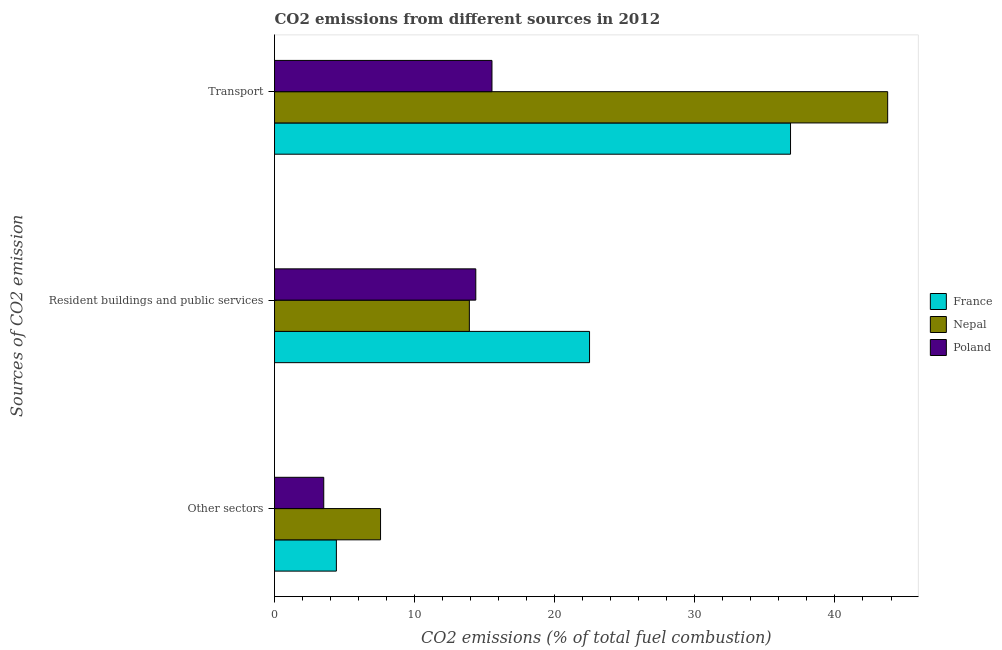Are the number of bars on each tick of the Y-axis equal?
Your response must be concise. Yes. How many bars are there on the 2nd tick from the top?
Your answer should be very brief. 3. What is the label of the 1st group of bars from the top?
Provide a short and direct response. Transport. What is the percentage of co2 emissions from resident buildings and public services in France?
Offer a very short reply. 22.48. Across all countries, what is the maximum percentage of co2 emissions from other sectors?
Offer a terse response. 7.57. Across all countries, what is the minimum percentage of co2 emissions from transport?
Make the answer very short. 15.52. In which country was the percentage of co2 emissions from resident buildings and public services maximum?
Your answer should be very brief. France. In which country was the percentage of co2 emissions from resident buildings and public services minimum?
Offer a very short reply. Nepal. What is the total percentage of co2 emissions from transport in the graph?
Make the answer very short. 96.11. What is the difference between the percentage of co2 emissions from transport in Poland and that in France?
Your answer should be very brief. -21.31. What is the difference between the percentage of co2 emissions from resident buildings and public services in Poland and the percentage of co2 emissions from other sectors in France?
Keep it short and to the point. 9.95. What is the average percentage of co2 emissions from resident buildings and public services per country?
Ensure brevity in your answer.  16.92. What is the difference between the percentage of co2 emissions from resident buildings and public services and percentage of co2 emissions from transport in Nepal?
Make the answer very short. -29.86. In how many countries, is the percentage of co2 emissions from other sectors greater than 2 %?
Your response must be concise. 3. What is the ratio of the percentage of co2 emissions from transport in Nepal to that in France?
Make the answer very short. 1.19. Is the percentage of co2 emissions from transport in Nepal less than that in Poland?
Provide a short and direct response. No. Is the difference between the percentage of co2 emissions from resident buildings and public services in Nepal and Poland greater than the difference between the percentage of co2 emissions from other sectors in Nepal and Poland?
Give a very brief answer. No. What is the difference between the highest and the second highest percentage of co2 emissions from transport?
Give a very brief answer. 6.93. What is the difference between the highest and the lowest percentage of co2 emissions from other sectors?
Keep it short and to the point. 4.05. In how many countries, is the percentage of co2 emissions from other sectors greater than the average percentage of co2 emissions from other sectors taken over all countries?
Your response must be concise. 1. Is the sum of the percentage of co2 emissions from transport in Nepal and Poland greater than the maximum percentage of co2 emissions from other sectors across all countries?
Provide a succinct answer. Yes. What does the 2nd bar from the bottom in Other sectors represents?
Your response must be concise. Nepal. Is it the case that in every country, the sum of the percentage of co2 emissions from other sectors and percentage of co2 emissions from resident buildings and public services is greater than the percentage of co2 emissions from transport?
Give a very brief answer. No. How many bars are there?
Provide a succinct answer. 9. What is the difference between two consecutive major ticks on the X-axis?
Your answer should be very brief. 10. Does the graph contain grids?
Provide a short and direct response. No. How many legend labels are there?
Make the answer very short. 3. How are the legend labels stacked?
Provide a succinct answer. Vertical. What is the title of the graph?
Your answer should be very brief. CO2 emissions from different sources in 2012. What is the label or title of the X-axis?
Make the answer very short. CO2 emissions (% of total fuel combustion). What is the label or title of the Y-axis?
Ensure brevity in your answer.  Sources of CO2 emission. What is the CO2 emissions (% of total fuel combustion) of France in Other sectors?
Make the answer very short. 4.41. What is the CO2 emissions (% of total fuel combustion) of Nepal in Other sectors?
Make the answer very short. 7.57. What is the CO2 emissions (% of total fuel combustion) in Poland in Other sectors?
Provide a short and direct response. 3.51. What is the CO2 emissions (% of total fuel combustion) of France in Resident buildings and public services?
Provide a succinct answer. 22.48. What is the CO2 emissions (% of total fuel combustion) of Nepal in Resident buildings and public services?
Provide a succinct answer. 13.91. What is the CO2 emissions (% of total fuel combustion) of Poland in Resident buildings and public services?
Offer a very short reply. 14.36. What is the CO2 emissions (% of total fuel combustion) in France in Transport?
Provide a succinct answer. 36.83. What is the CO2 emissions (% of total fuel combustion) of Nepal in Transport?
Keep it short and to the point. 43.76. What is the CO2 emissions (% of total fuel combustion) of Poland in Transport?
Your answer should be very brief. 15.52. Across all Sources of CO2 emission, what is the maximum CO2 emissions (% of total fuel combustion) in France?
Offer a terse response. 36.83. Across all Sources of CO2 emission, what is the maximum CO2 emissions (% of total fuel combustion) of Nepal?
Make the answer very short. 43.76. Across all Sources of CO2 emission, what is the maximum CO2 emissions (% of total fuel combustion) in Poland?
Provide a succinct answer. 15.52. Across all Sources of CO2 emission, what is the minimum CO2 emissions (% of total fuel combustion) in France?
Make the answer very short. 4.41. Across all Sources of CO2 emission, what is the minimum CO2 emissions (% of total fuel combustion) of Nepal?
Give a very brief answer. 7.57. Across all Sources of CO2 emission, what is the minimum CO2 emissions (% of total fuel combustion) of Poland?
Provide a succinct answer. 3.51. What is the total CO2 emissions (% of total fuel combustion) in France in the graph?
Provide a short and direct response. 63.73. What is the total CO2 emissions (% of total fuel combustion) in Nepal in the graph?
Provide a short and direct response. 65.24. What is the total CO2 emissions (% of total fuel combustion) in Poland in the graph?
Provide a succinct answer. 33.4. What is the difference between the CO2 emissions (% of total fuel combustion) of France in Other sectors and that in Resident buildings and public services?
Your answer should be very brief. -18.07. What is the difference between the CO2 emissions (% of total fuel combustion) of Nepal in Other sectors and that in Resident buildings and public services?
Provide a short and direct response. -6.34. What is the difference between the CO2 emissions (% of total fuel combustion) in Poland in Other sectors and that in Resident buildings and public services?
Make the answer very short. -10.85. What is the difference between the CO2 emissions (% of total fuel combustion) in France in Other sectors and that in Transport?
Provide a succinct answer. -32.41. What is the difference between the CO2 emissions (% of total fuel combustion) of Nepal in Other sectors and that in Transport?
Provide a short and direct response. -36.2. What is the difference between the CO2 emissions (% of total fuel combustion) of Poland in Other sectors and that in Transport?
Your response must be concise. -12.01. What is the difference between the CO2 emissions (% of total fuel combustion) in France in Resident buildings and public services and that in Transport?
Your answer should be very brief. -14.35. What is the difference between the CO2 emissions (% of total fuel combustion) in Nepal in Resident buildings and public services and that in Transport?
Your answer should be very brief. -29.86. What is the difference between the CO2 emissions (% of total fuel combustion) of Poland in Resident buildings and public services and that in Transport?
Give a very brief answer. -1.15. What is the difference between the CO2 emissions (% of total fuel combustion) in France in Other sectors and the CO2 emissions (% of total fuel combustion) in Nepal in Resident buildings and public services?
Make the answer very short. -9.49. What is the difference between the CO2 emissions (% of total fuel combustion) of France in Other sectors and the CO2 emissions (% of total fuel combustion) of Poland in Resident buildings and public services?
Keep it short and to the point. -9.95. What is the difference between the CO2 emissions (% of total fuel combustion) of Nepal in Other sectors and the CO2 emissions (% of total fuel combustion) of Poland in Resident buildings and public services?
Make the answer very short. -6.8. What is the difference between the CO2 emissions (% of total fuel combustion) of France in Other sectors and the CO2 emissions (% of total fuel combustion) of Nepal in Transport?
Provide a short and direct response. -39.35. What is the difference between the CO2 emissions (% of total fuel combustion) in France in Other sectors and the CO2 emissions (% of total fuel combustion) in Poland in Transport?
Offer a very short reply. -11.1. What is the difference between the CO2 emissions (% of total fuel combustion) of Nepal in Other sectors and the CO2 emissions (% of total fuel combustion) of Poland in Transport?
Your response must be concise. -7.95. What is the difference between the CO2 emissions (% of total fuel combustion) in France in Resident buildings and public services and the CO2 emissions (% of total fuel combustion) in Nepal in Transport?
Ensure brevity in your answer.  -21.28. What is the difference between the CO2 emissions (% of total fuel combustion) of France in Resident buildings and public services and the CO2 emissions (% of total fuel combustion) of Poland in Transport?
Keep it short and to the point. 6.96. What is the difference between the CO2 emissions (% of total fuel combustion) of Nepal in Resident buildings and public services and the CO2 emissions (% of total fuel combustion) of Poland in Transport?
Provide a succinct answer. -1.61. What is the average CO2 emissions (% of total fuel combustion) in France per Sources of CO2 emission?
Your response must be concise. 21.24. What is the average CO2 emissions (% of total fuel combustion) of Nepal per Sources of CO2 emission?
Offer a very short reply. 21.75. What is the average CO2 emissions (% of total fuel combustion) in Poland per Sources of CO2 emission?
Provide a succinct answer. 11.13. What is the difference between the CO2 emissions (% of total fuel combustion) of France and CO2 emissions (% of total fuel combustion) of Nepal in Other sectors?
Ensure brevity in your answer.  -3.15. What is the difference between the CO2 emissions (% of total fuel combustion) in France and CO2 emissions (% of total fuel combustion) in Poland in Other sectors?
Offer a terse response. 0.9. What is the difference between the CO2 emissions (% of total fuel combustion) of Nepal and CO2 emissions (% of total fuel combustion) of Poland in Other sectors?
Make the answer very short. 4.05. What is the difference between the CO2 emissions (% of total fuel combustion) of France and CO2 emissions (% of total fuel combustion) of Nepal in Resident buildings and public services?
Your response must be concise. 8.58. What is the difference between the CO2 emissions (% of total fuel combustion) of France and CO2 emissions (% of total fuel combustion) of Poland in Resident buildings and public services?
Provide a succinct answer. 8.12. What is the difference between the CO2 emissions (% of total fuel combustion) of Nepal and CO2 emissions (% of total fuel combustion) of Poland in Resident buildings and public services?
Your answer should be compact. -0.46. What is the difference between the CO2 emissions (% of total fuel combustion) of France and CO2 emissions (% of total fuel combustion) of Nepal in Transport?
Your answer should be very brief. -6.93. What is the difference between the CO2 emissions (% of total fuel combustion) of France and CO2 emissions (% of total fuel combustion) of Poland in Transport?
Make the answer very short. 21.31. What is the difference between the CO2 emissions (% of total fuel combustion) in Nepal and CO2 emissions (% of total fuel combustion) in Poland in Transport?
Give a very brief answer. 28.24. What is the ratio of the CO2 emissions (% of total fuel combustion) in France in Other sectors to that in Resident buildings and public services?
Ensure brevity in your answer.  0.2. What is the ratio of the CO2 emissions (% of total fuel combustion) in Nepal in Other sectors to that in Resident buildings and public services?
Your answer should be very brief. 0.54. What is the ratio of the CO2 emissions (% of total fuel combustion) of Poland in Other sectors to that in Resident buildings and public services?
Your answer should be very brief. 0.24. What is the ratio of the CO2 emissions (% of total fuel combustion) in France in Other sectors to that in Transport?
Give a very brief answer. 0.12. What is the ratio of the CO2 emissions (% of total fuel combustion) in Nepal in Other sectors to that in Transport?
Your answer should be compact. 0.17. What is the ratio of the CO2 emissions (% of total fuel combustion) of Poland in Other sectors to that in Transport?
Give a very brief answer. 0.23. What is the ratio of the CO2 emissions (% of total fuel combustion) in France in Resident buildings and public services to that in Transport?
Give a very brief answer. 0.61. What is the ratio of the CO2 emissions (% of total fuel combustion) in Nepal in Resident buildings and public services to that in Transport?
Ensure brevity in your answer.  0.32. What is the ratio of the CO2 emissions (% of total fuel combustion) in Poland in Resident buildings and public services to that in Transport?
Ensure brevity in your answer.  0.93. What is the difference between the highest and the second highest CO2 emissions (% of total fuel combustion) in France?
Give a very brief answer. 14.35. What is the difference between the highest and the second highest CO2 emissions (% of total fuel combustion) in Nepal?
Provide a succinct answer. 29.86. What is the difference between the highest and the second highest CO2 emissions (% of total fuel combustion) of Poland?
Keep it short and to the point. 1.15. What is the difference between the highest and the lowest CO2 emissions (% of total fuel combustion) in France?
Give a very brief answer. 32.41. What is the difference between the highest and the lowest CO2 emissions (% of total fuel combustion) in Nepal?
Ensure brevity in your answer.  36.2. What is the difference between the highest and the lowest CO2 emissions (% of total fuel combustion) in Poland?
Keep it short and to the point. 12.01. 